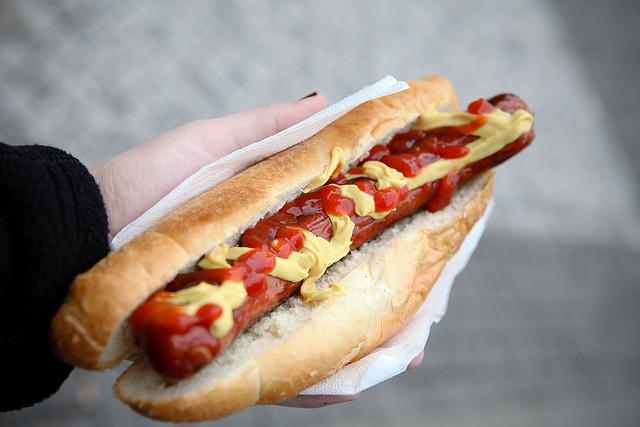What is the person holding the hot dog in?
Quick response, please. Napkin. What is the yellow stuff on the hot dog?
Be succinct. Mustard. How many dogs?
Write a very short answer. 1. What color is the package?
Give a very brief answer. White. 